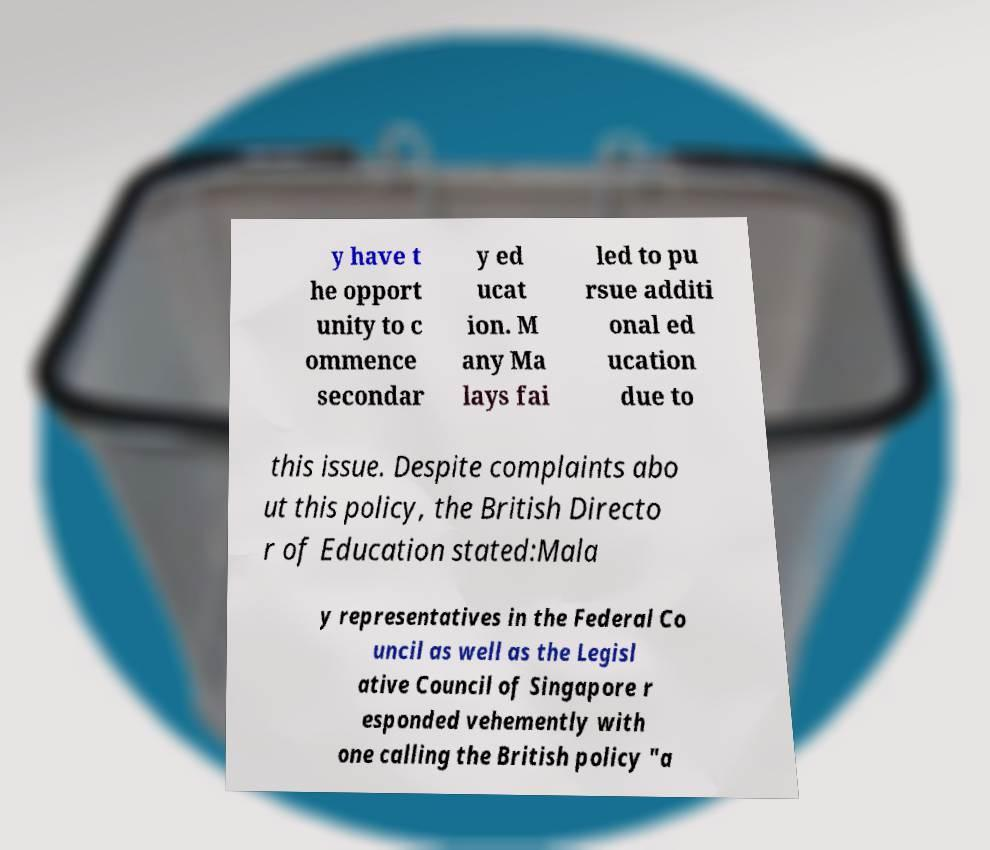Please read and relay the text visible in this image. What does it say? y have t he opport unity to c ommence secondar y ed ucat ion. M any Ma lays fai led to pu rsue additi onal ed ucation due to this issue. Despite complaints abo ut this policy, the British Directo r of Education stated:Mala y representatives in the Federal Co uncil as well as the Legisl ative Council of Singapore r esponded vehemently with one calling the British policy "a 